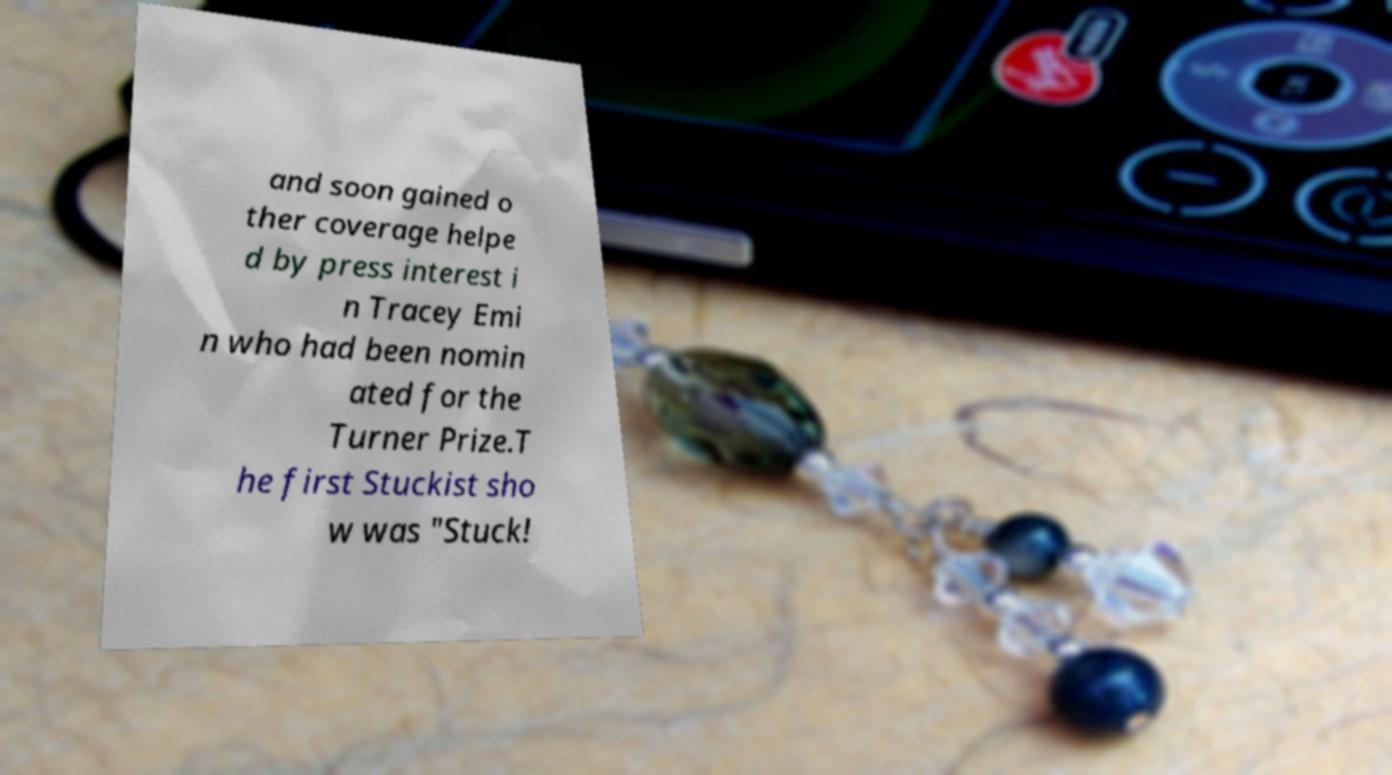Can you accurately transcribe the text from the provided image for me? and soon gained o ther coverage helpe d by press interest i n Tracey Emi n who had been nomin ated for the Turner Prize.T he first Stuckist sho w was "Stuck! 